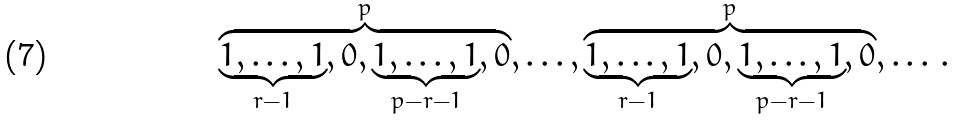Convert formula to latex. <formula><loc_0><loc_0><loc_500><loc_500>\overbrace { \underbrace { 1 , \dots , 1 } _ { r - 1 } , 0 , \underbrace { 1 , \dots , 1 } _ { p - r - 1 } , 0 } ^ { p } , \dots , \overbrace { \underbrace { 1 , \dots , 1 } _ { r - 1 } , 0 , \underbrace { 1 , \dots , 1 } _ { p - r - 1 } , 0 } ^ { p } , \dots \, .</formula> 